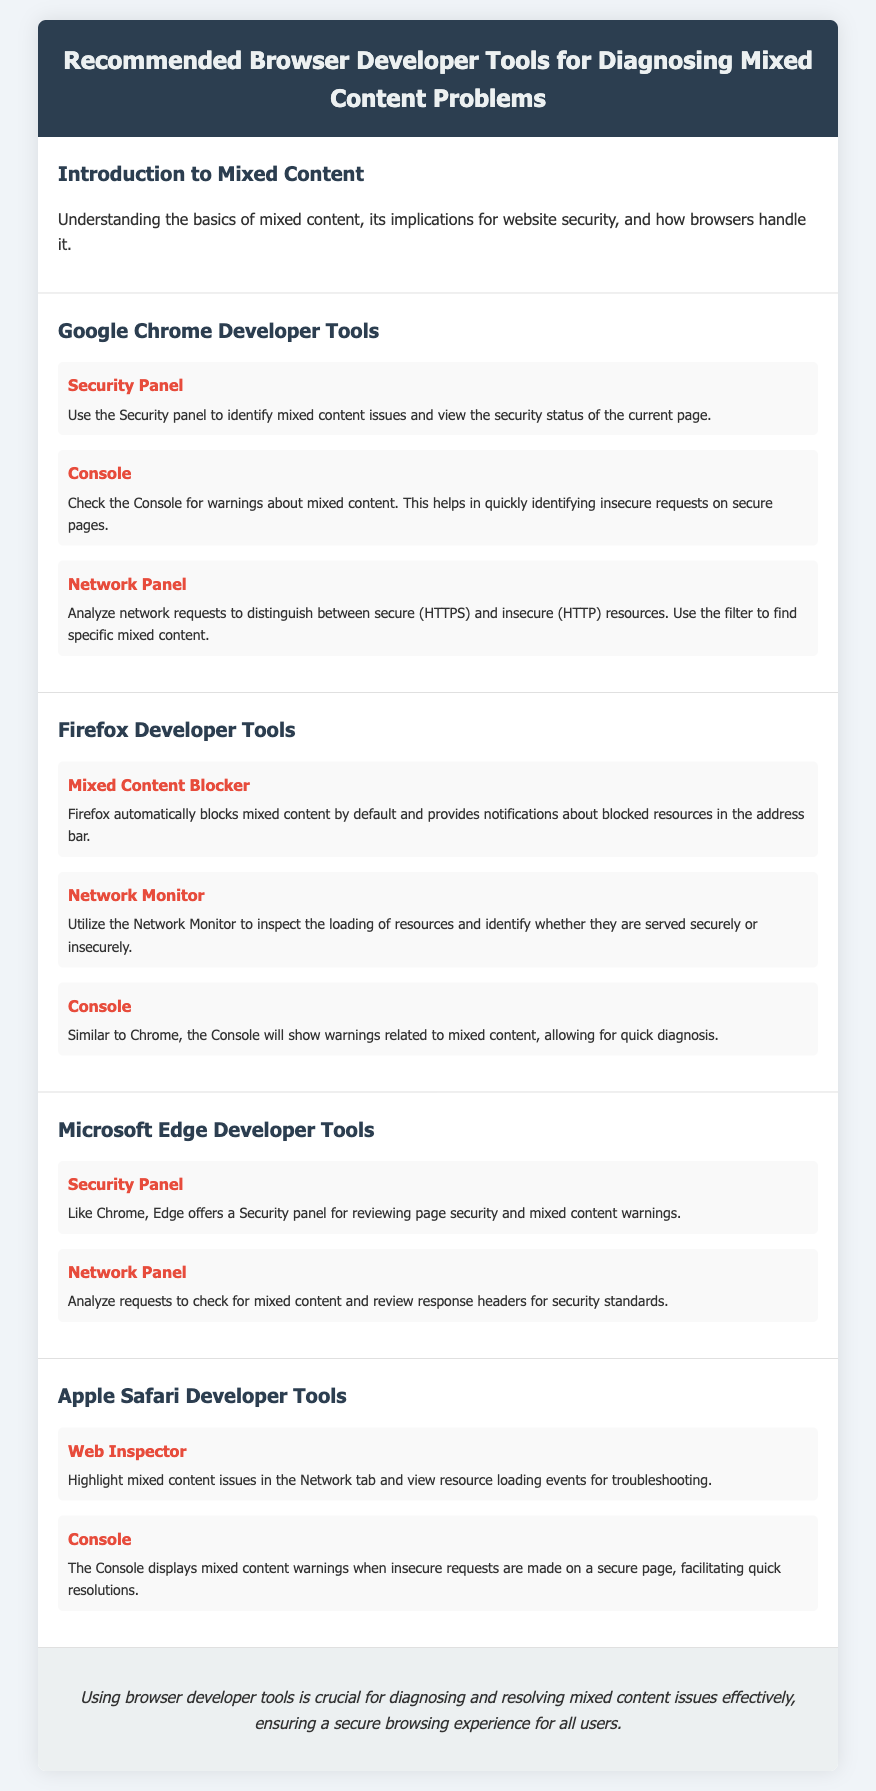What is the title of the document? The title of the document is presented in the header section.
Answer: Recommended Browser Developer Tools for Diagnosing Mixed Content Problems Which browser developer tool provides mixed content warnings in Firefox? The specific tool mentioned for mixed content notifications in Firefox is found in the Firefox Developer Tools section.
Answer: Mixed Content Blocker What panel is used in Microsoft Edge for reviewing mixed content warnings? The document specifies the tool utilized in Microsoft Edge for this purpose under its respective section.
Answer: Security Panel How many Chrome developer tools are listed for diagnosing mixed content? The number of tools listed in the Chrome Developer Tools section indicates how many are recommended for this task.
Answer: Three Which tool helps analyze network requests for mixed content in Google Chrome? The tool that assists with this function in Google Chrome is described in the relevant section.
Answer: Network Panel What is the primary function of the Console in browser developer tools? The document describes the role of the Console across various browsers, focusing on its capability.
Answer: Show warnings In which section is the introduction to mixed content discussed? The section title clearly indicates where the introduction is located within the document.
Answer: Introduction to Mixed Content What is the concluding message of the document? The last section summarizes the importance of using the tools mentioned in relation to mixed content issues.
Answer: Crucial for diagnosing and resolving mixed content issues Which developer tool in Safari highlights mixed content issues? The document specifies the tool that provides this functionality in the Safari Developer Tools section.
Answer: Web Inspector 